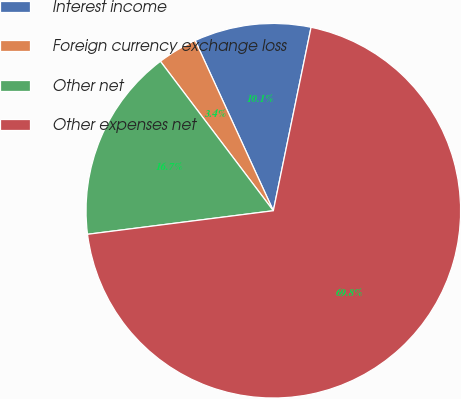Convert chart. <chart><loc_0><loc_0><loc_500><loc_500><pie_chart><fcel>Interest income<fcel>Foreign currency exchange loss<fcel>Other net<fcel>Other expenses net<nl><fcel>10.08%<fcel>3.45%<fcel>16.71%<fcel>69.77%<nl></chart> 